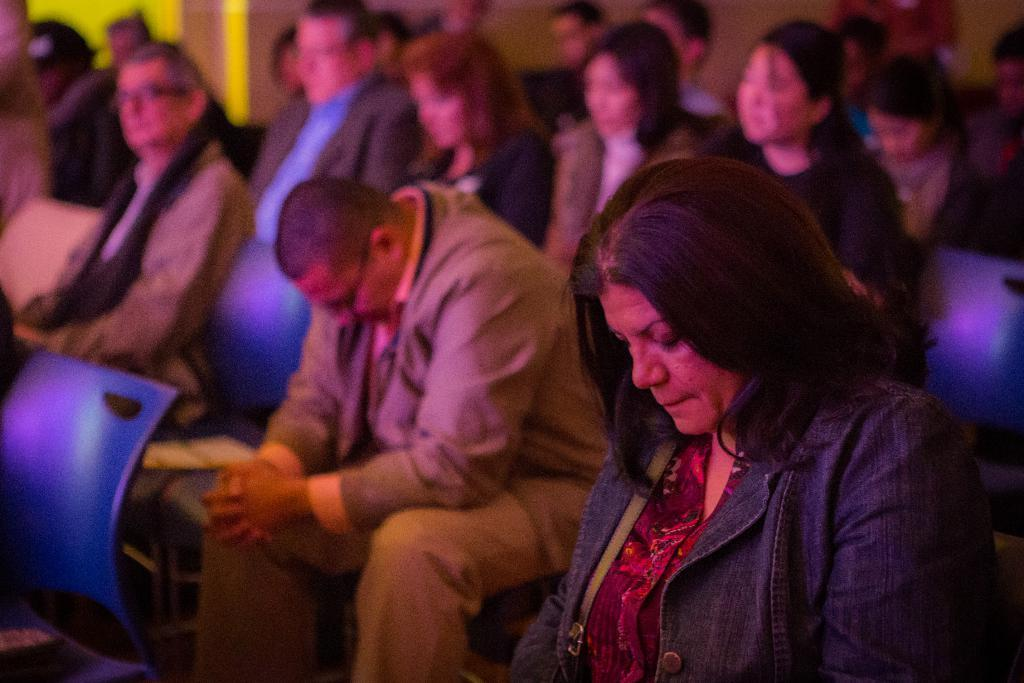What is happening in the image? There is a group of people in the image. What are the people doing in the image? The people are sitting on chairs. What can be seen in the background of the image? There is a wall visible in the background of the image. What is the design of the theory in the image? There is no theory or design present in the image; it features a group of people sitting on chairs with a wall in the background. 